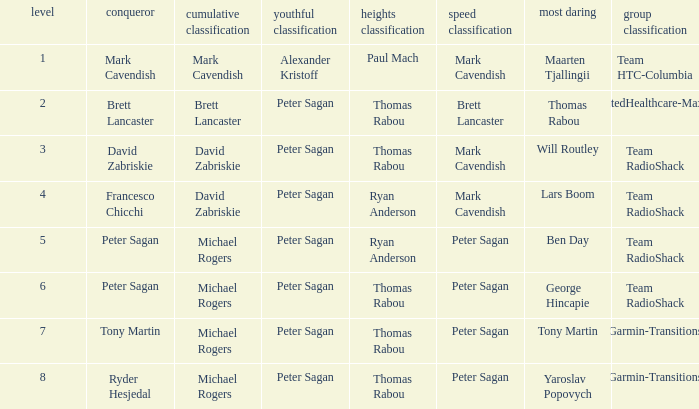When peter sagan secured the youth classification and thomas rabou achieved the most courageous, who emerged victorious in the sprint classification? Brett Lancaster. 